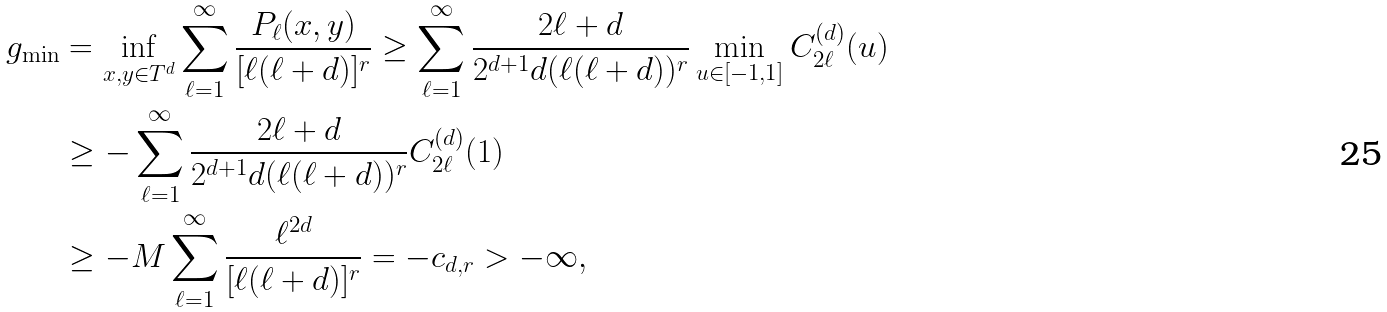Convert formula to latex. <formula><loc_0><loc_0><loc_500><loc_500>g _ { \min } & = \inf _ { x , y \in T ^ { d } } \sum _ { \ell = 1 } ^ { \infty } \frac { P _ { \ell } ( x , y ) } { [ \ell ( \ell + d ) ] ^ { r } } \geq \sum _ { \ell = 1 } ^ { \infty } \frac { 2 \ell + d } { 2 ^ { d + 1 } d ( \ell ( \ell + d ) ) ^ { r } } \min _ { u \in [ - 1 , 1 ] } C _ { 2 \ell } ^ { ( d ) } ( u ) \\ & \geq - \sum _ { \ell = 1 } ^ { \infty } \frac { 2 \ell + d } { 2 ^ { d + 1 } d ( \ell ( \ell + d ) ) ^ { r } } C _ { 2 \ell } ^ { ( d ) } ( 1 ) \\ & \geq - M \sum _ { \ell = 1 } ^ { \infty } \frac { \ell ^ { 2 d } } { [ \ell ( \ell + d ) ] ^ { r } } = - c _ { d , r } > - \infty ,</formula> 